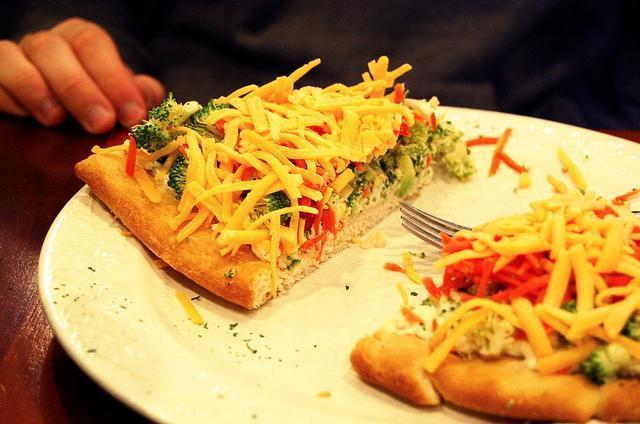How many slices of pizza do you see?
Give a very brief answer. 2. How many pizzas can be seen?
Give a very brief answer. 2. 